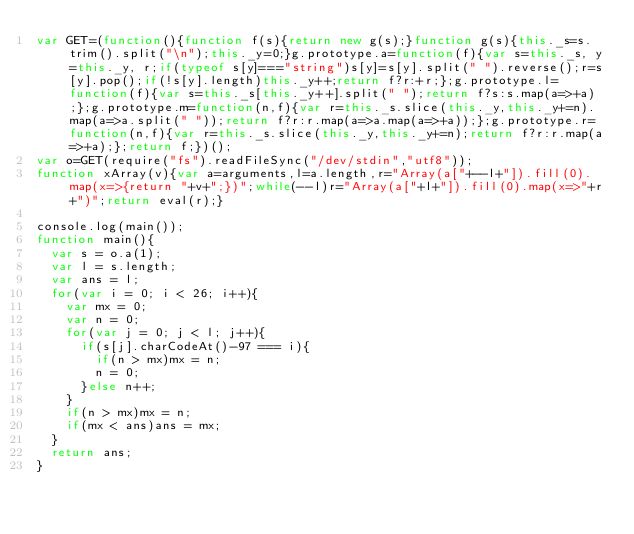<code> <loc_0><loc_0><loc_500><loc_500><_JavaScript_>var GET=(function(){function f(s){return new g(s);}function g(s){this._s=s.trim().split("\n");this._y=0;}g.prototype.a=function(f){var s=this._s, y=this._y, r;if(typeof s[y]==="string")s[y]=s[y].split(" ").reverse();r=s[y].pop();if(!s[y].length)this._y++;return f?r:+r;};g.prototype.l=function(f){var s=this._s[this._y++].split(" ");return f?s:s.map(a=>+a);};g.prototype.m=function(n,f){var r=this._s.slice(this._y,this._y+=n).map(a=>a.split(" "));return f?r:r.map(a=>a.map(a=>+a));};g.prototype.r=function(n,f){var r=this._s.slice(this._y,this._y+=n);return f?r:r.map(a=>+a);};return f;})();
var o=GET(require("fs").readFileSync("/dev/stdin","utf8"));
function xArray(v){var a=arguments,l=a.length,r="Array(a["+--l+"]).fill(0).map(x=>{return "+v+";})";while(--l)r="Array(a["+l+"]).fill(0).map(x=>"+r+")";return eval(r);}

console.log(main());
function main(){
  var s = o.a(1);
  var l = s.length;
  var ans = l;
  for(var i = 0; i < 26; i++){
    var mx = 0;
    var n = 0;
    for(var j = 0; j < l; j++){
      if(s[j].charCodeAt()-97 === i){
        if(n > mx)mx = n;
        n = 0;
      }else n++;
    }
    if(n > mx)mx = n;
    if(mx < ans)ans = mx;
  }
  return ans;
}</code> 